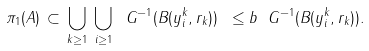<formula> <loc_0><loc_0><loc_500><loc_500>\pi _ { 1 } ( A ) \, \subset \, \bigcup _ { k \geq 1 } \, \bigcup _ { \, i \geq 1 } \ G ^ { - 1 } ( B ( y _ { i } ^ { k } , r _ { k } ) ) \ \leq b \ G ^ { - 1 } ( B ( y _ { i } ^ { k } , r _ { k } ) ) .</formula> 